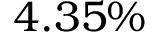Convert formula to latex. <formula><loc_0><loc_0><loc_500><loc_500>4 . 3 5 \%</formula> 